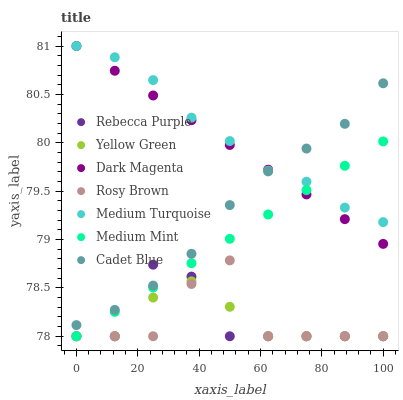Does Yellow Green have the minimum area under the curve?
Answer yes or no. Yes. Does Medium Turquoise have the maximum area under the curve?
Answer yes or no. Yes. Does Cadet Blue have the minimum area under the curve?
Answer yes or no. No. Does Cadet Blue have the maximum area under the curve?
Answer yes or no. No. Is Medium Mint the smoothest?
Answer yes or no. Yes. Is Rebecca Purple the roughest?
Answer yes or no. Yes. Is Cadet Blue the smoothest?
Answer yes or no. No. Is Cadet Blue the roughest?
Answer yes or no. No. Does Medium Mint have the lowest value?
Answer yes or no. Yes. Does Cadet Blue have the lowest value?
Answer yes or no. No. Does Medium Turquoise have the highest value?
Answer yes or no. Yes. Does Cadet Blue have the highest value?
Answer yes or no. No. Is Yellow Green less than Medium Turquoise?
Answer yes or no. Yes. Is Cadet Blue greater than Yellow Green?
Answer yes or no. Yes. Does Medium Mint intersect Yellow Green?
Answer yes or no. Yes. Is Medium Mint less than Yellow Green?
Answer yes or no. No. Is Medium Mint greater than Yellow Green?
Answer yes or no. No. Does Yellow Green intersect Medium Turquoise?
Answer yes or no. No. 